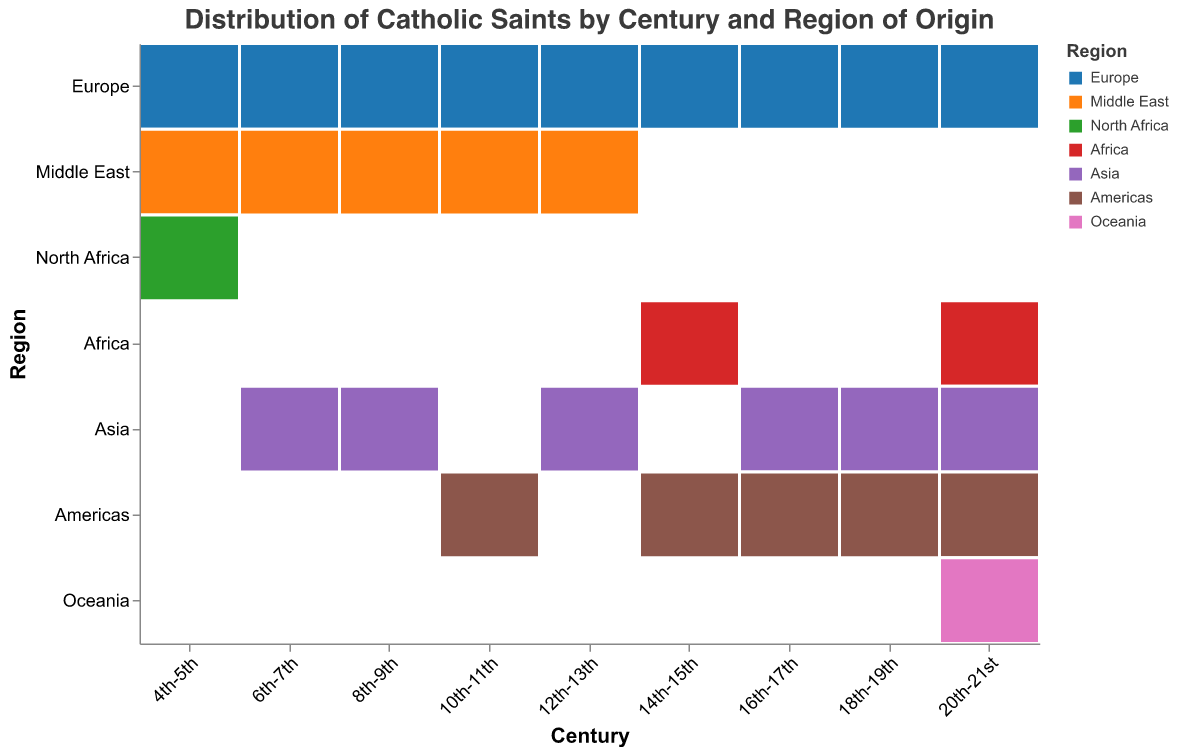What's the title of the figure? The title of the figure is typically placed at the top and is clearly indicated.
Answer: Distribution of Catholic Saints by Century and Region of Origin Which region has the highest number of saints in the 20th-21st century? By looking at the size of the blocks for each region in the 20th-21st century column, the largest block corresponds to Europe.
Answer: Europe In which century did Asia see the highest number of saints? Checking the size of the blocks marked for Asia across different centuries, the 20th-21st century block is the largest.
Answer: 20th-21st century What's the total number of saints in the 18th-19th centuries? Add the number of saints from all regions in the 18th-19th century: 40 (Europe) + 10 (Asia) + 15 (Americas) = 65.
Answer: 65 How does the number of saints from Europe in the 4th-5th century compare to that in the 10th-11th century? Compare the sizes of the blocks for Europe in the 4th-5th century (12 saints) and 10th-11th century (22 saints). The number in the 10th-11th century is higher.
Answer: Higher Which regions have saints represented for the first time in the 14th-15th century? Look for regions with data appearing for the first time in the 14th-15th century column, which are Africa and Americas.
Answer: Africa, Americas What is the difference in the number of saints between Europe and Asia in the 16th-17th century? Subtract the number of saints in Asia (6) from the number of saints in Europe (35). The difference is 29.
Answer: 29 How many centuries show saints originating from the Middle East? Count the number of columns that have a block for the Middle East across all centuries: 4th-5th, 6th-7th, 8th-9th, 10th-11th, 12th-13th. There are 5 centuries.
Answer: 5 Which two regions show the biggest increase in saints from the 4th-5th century to the 20th-21st century? By comparing the visual sizes of the blocks from the 4th-5th century to the 20th-21st century, Africa and the Americas show notable increases.
Answer: Africa, Americas 